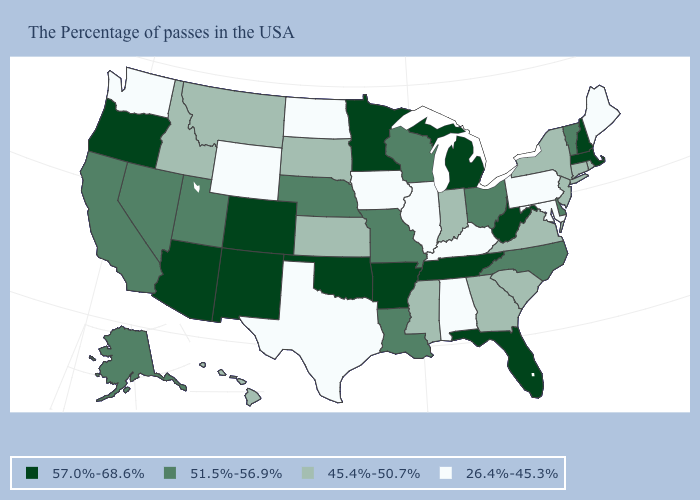Which states have the lowest value in the USA?
Short answer required. Maine, Maryland, Pennsylvania, Kentucky, Alabama, Illinois, Iowa, Texas, North Dakota, Wyoming, Washington. What is the value of Colorado?
Be succinct. 57.0%-68.6%. Which states have the highest value in the USA?
Write a very short answer. Massachusetts, New Hampshire, West Virginia, Florida, Michigan, Tennessee, Arkansas, Minnesota, Oklahoma, Colorado, New Mexico, Arizona, Oregon. Name the states that have a value in the range 26.4%-45.3%?
Keep it brief. Maine, Maryland, Pennsylvania, Kentucky, Alabama, Illinois, Iowa, Texas, North Dakota, Wyoming, Washington. Among the states that border Nevada , does Arizona have the highest value?
Write a very short answer. Yes. Does Alabama have a higher value than New York?
Answer briefly. No. Does Illinois have the lowest value in the MidWest?
Write a very short answer. Yes. Name the states that have a value in the range 57.0%-68.6%?
Quick response, please. Massachusetts, New Hampshire, West Virginia, Florida, Michigan, Tennessee, Arkansas, Minnesota, Oklahoma, Colorado, New Mexico, Arizona, Oregon. What is the lowest value in states that border California?
Be succinct. 51.5%-56.9%. Does the map have missing data?
Give a very brief answer. No. Which states have the lowest value in the USA?
Give a very brief answer. Maine, Maryland, Pennsylvania, Kentucky, Alabama, Illinois, Iowa, Texas, North Dakota, Wyoming, Washington. What is the value of Oklahoma?
Give a very brief answer. 57.0%-68.6%. Does Vermont have the same value as Hawaii?
Answer briefly. No. Among the states that border Nebraska , which have the highest value?
Keep it brief. Colorado. Is the legend a continuous bar?
Quick response, please. No. 